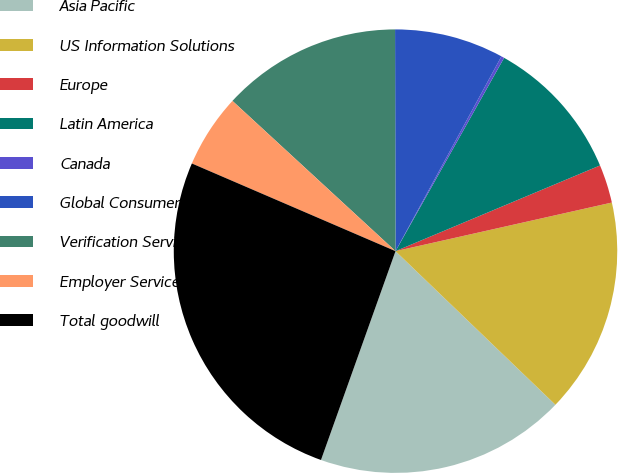<chart> <loc_0><loc_0><loc_500><loc_500><pie_chart><fcel>Asia Pacific<fcel>US Information Solutions<fcel>Europe<fcel>Latin America<fcel>Canada<fcel>Global Consumer Solutions<fcel>Verification Services<fcel>Employer Services<fcel>Total goodwill<nl><fcel>18.28%<fcel>15.7%<fcel>2.8%<fcel>10.54%<fcel>0.22%<fcel>7.96%<fcel>13.12%<fcel>5.38%<fcel>26.02%<nl></chart> 